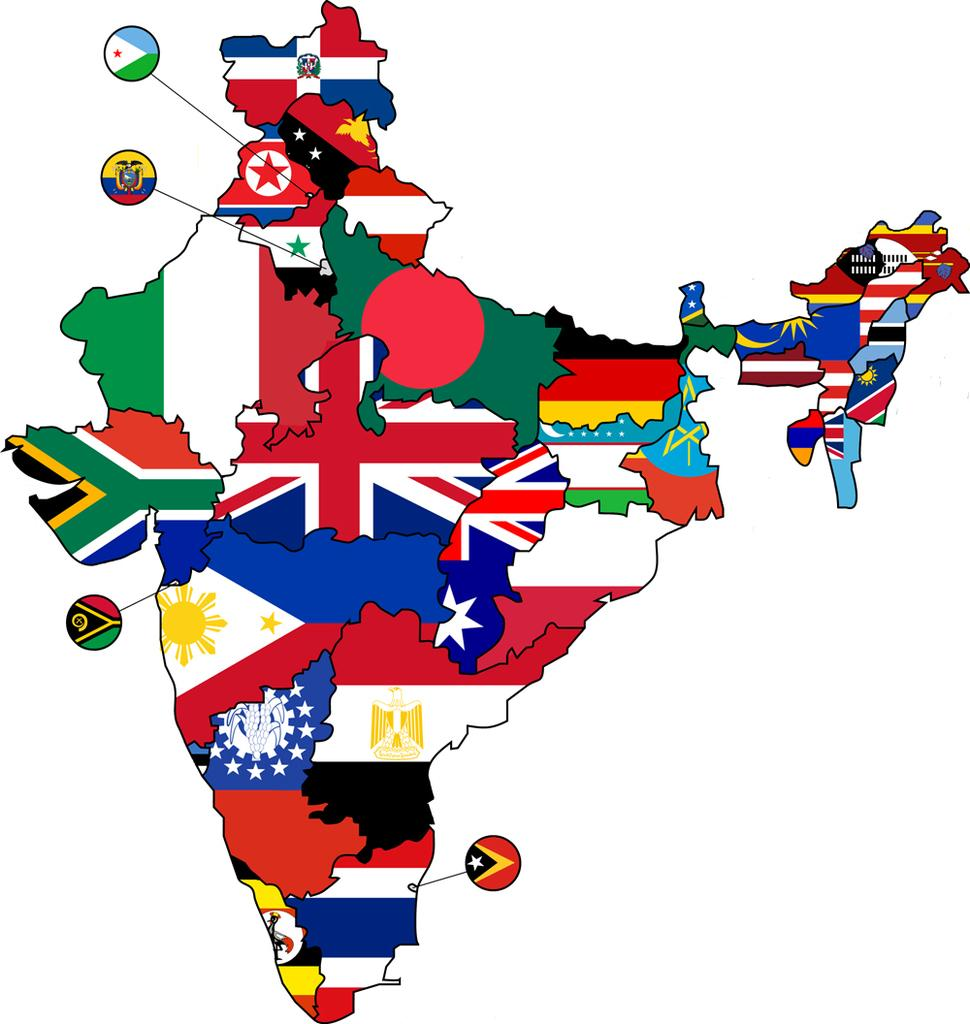What is the main subject of the image? The main subject of the image is a map of India. How is the map of India depicted in the image? The map is made with different flags of countries. What color is the background of the image? The background of the image is white. What type of box is being used to store the map of India in the image? There is no box present in the image; the map of India is displayed on a white background. 